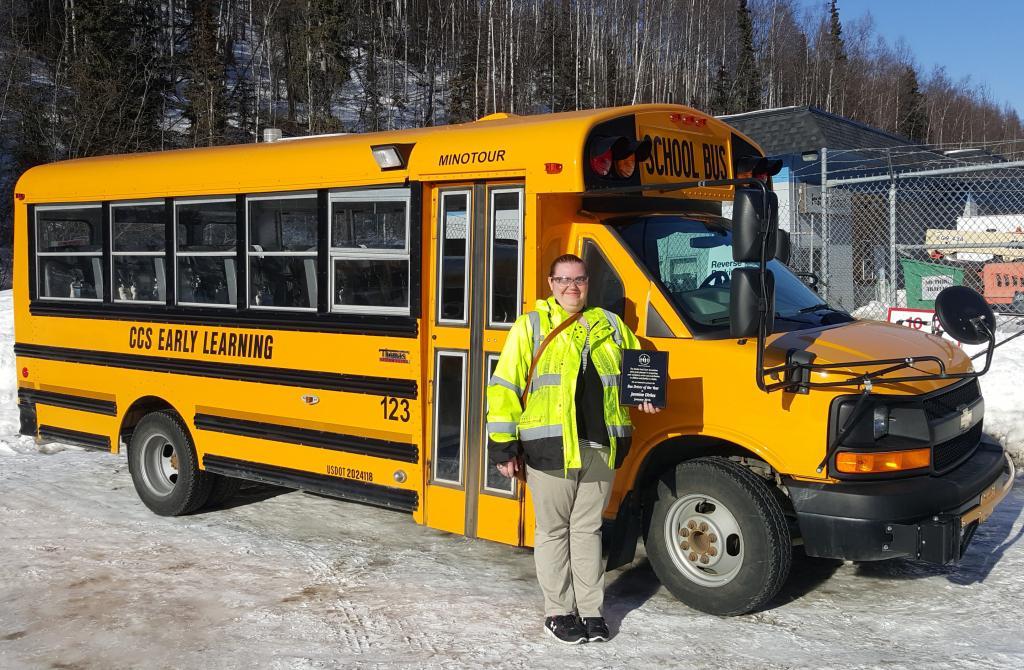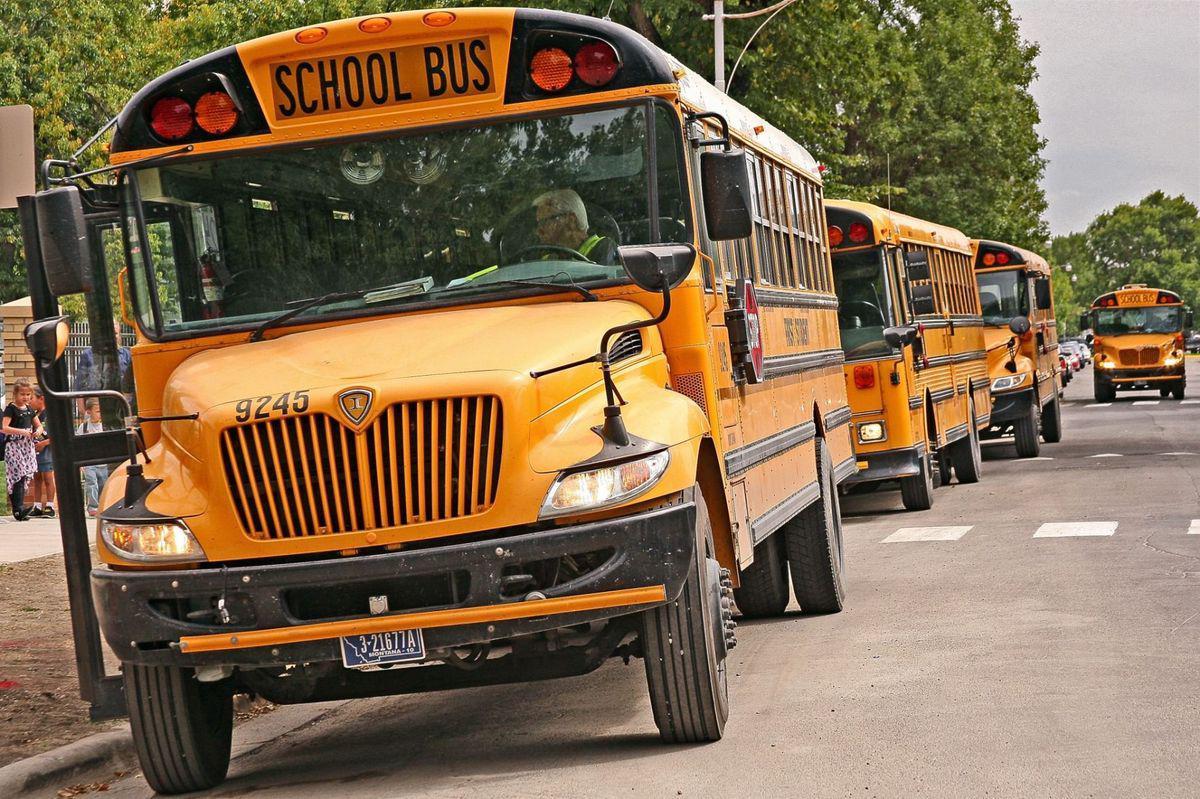The first image is the image on the left, the second image is the image on the right. For the images shown, is this caption "Buses are lined up side by side in at least one of the images." true? Answer yes or no. No. 